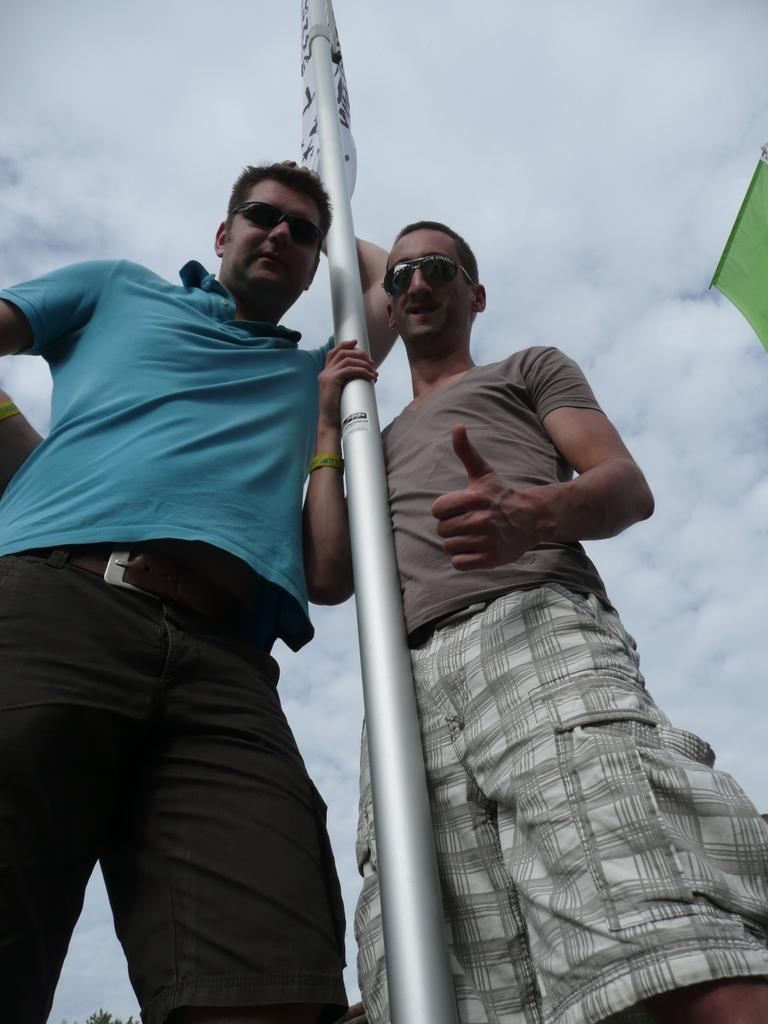How would you summarize this image in a sentence or two? In the center of the image we can see me standing at the pole. In the background we can see sky and clouds. 